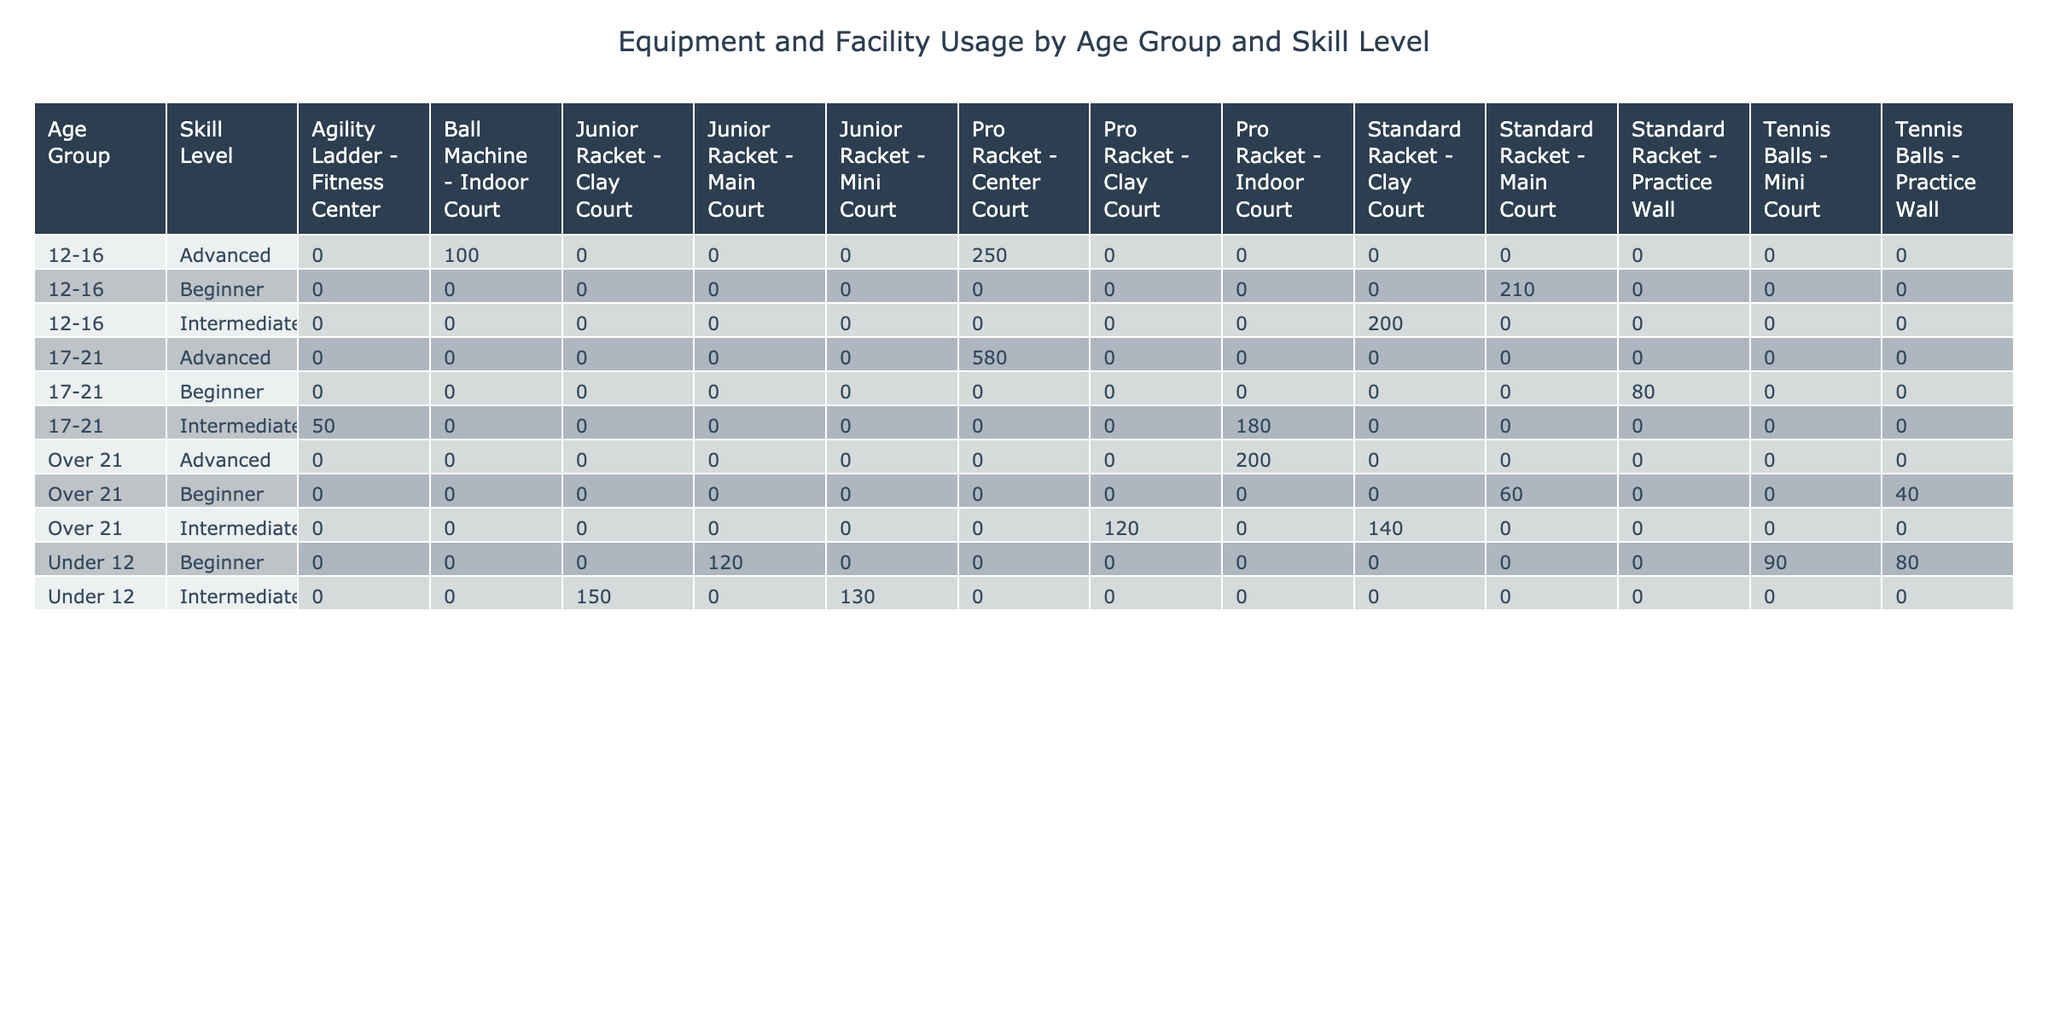What is the total usage hours for Junior Racket in the Under 12 age group? In the Under 12 age group, the usage hours for Junior Racket can be found under Beginner and Intermediate skill levels. Beginner has 120 hours, and Intermediate has 130 hours. Adding these gives us 120 + 130 = 250 hours total.
Answer: 250 Which facility has the highest total usage hours for Advanced skill level? For the Advanced skill level, we need to look at the usage hours in each facility: Center Court (250 hours for 12-16 and 280 hours for 17-21) totals to 530 hours; Indoor Court (100 hours for 12-16, 300 hours for 17-21) totals to 300 hours. Center Court has the higher total of 530 hours.
Answer: Center Court Is there any equipment type with 0 usage hours in the table? By examining all the rows in the table, each equipment type shows usage hours greater than 0; thus, no equipment type has 0 usage hours recorded.
Answer: No What is the average usage hours for the Standard Racket across all age groups? The Standard Racket appears in 4 rows across different age groups: it has 100 hours (12-16, Beginner), 100 hours (12-16, Intermediate), 60 hours (Over 21, Beginner), and 140 hours (Over 21, Intermediate). The sum is 100 + 100 + 60 + 140 = 400 hours. To find the average we divide by the number of instances, which is 4: 400 / 4 = 100 hours average.
Answer: 100 How many usage hours does the Pro Racket have in total for all skill levels and age groups? The Pro Racket appears in three different age groups with the following usage hours: 250 hours (12-16, Advanced), 300 hours (17-21, Advanced), and 120 hours (17-21, Intermediate). Summing these gives 250 + 300 + 180 = 730 usage hours for the Pro Racket.
Answer: 730 